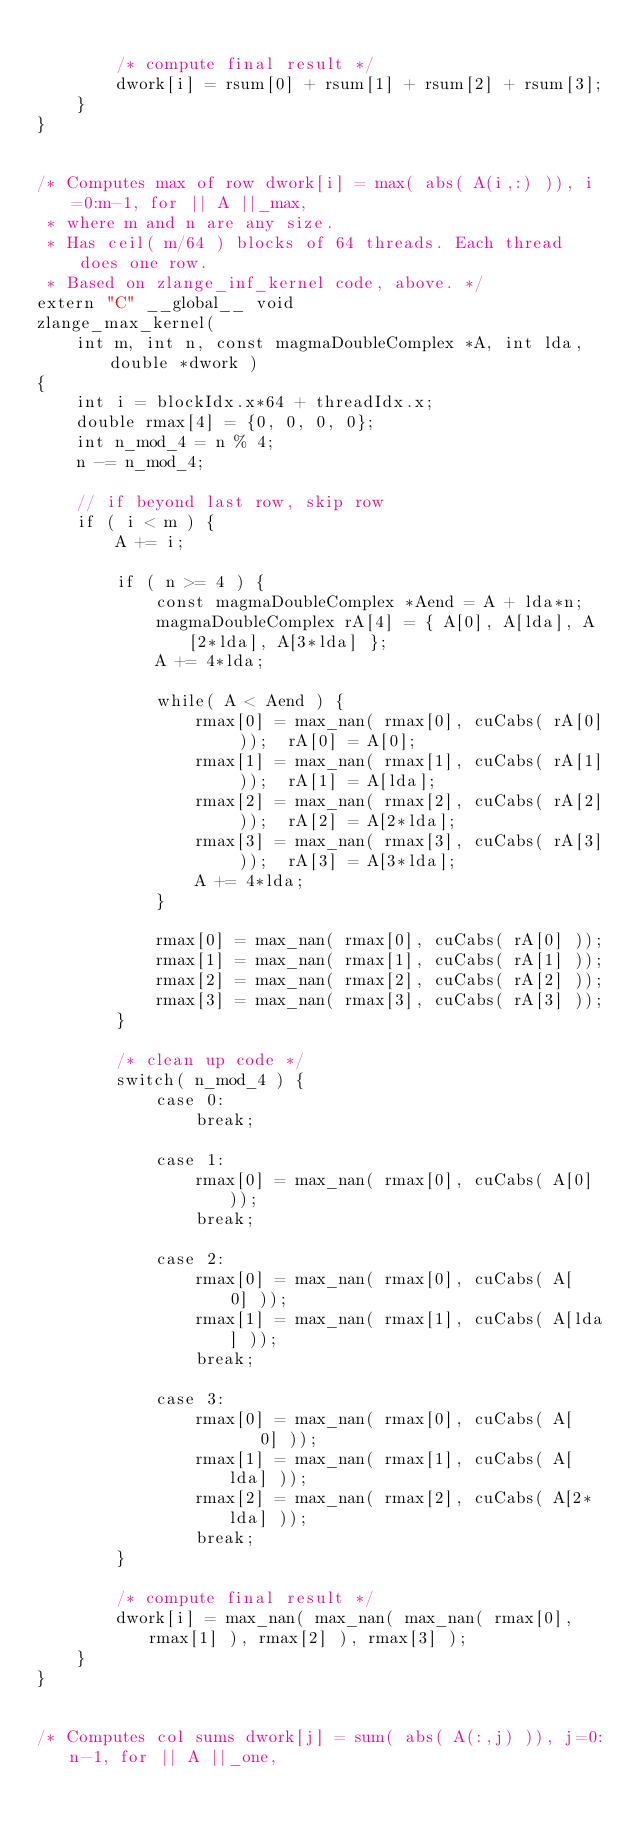Convert code to text. <code><loc_0><loc_0><loc_500><loc_500><_Cuda_>    
        /* compute final result */
        dwork[i] = rsum[0] + rsum[1] + rsum[2] + rsum[3];
    }
}


/* Computes max of row dwork[i] = max( abs( A(i,:) )), i=0:m-1, for || A ||_max,
 * where m and n are any size.
 * Has ceil( m/64 ) blocks of 64 threads. Each thread does one row.
 * Based on zlange_inf_kernel code, above. */
extern "C" __global__ void
zlange_max_kernel(
    int m, int n, const magmaDoubleComplex *A, int lda, double *dwork )
{
    int i = blockIdx.x*64 + threadIdx.x;
    double rmax[4] = {0, 0, 0, 0};
    int n_mod_4 = n % 4;
    n -= n_mod_4;
    
    // if beyond last row, skip row
    if ( i < m ) {
        A += i;
        
        if ( n >= 4 ) {
            const magmaDoubleComplex *Aend = A + lda*n;
            magmaDoubleComplex rA[4] = { A[0], A[lda], A[2*lda], A[3*lda] };
            A += 4*lda;
            
            while( A < Aend ) {
                rmax[0] = max_nan( rmax[0], cuCabs( rA[0] ));  rA[0] = A[0];
                rmax[1] = max_nan( rmax[1], cuCabs( rA[1] ));  rA[1] = A[lda];
                rmax[2] = max_nan( rmax[2], cuCabs( rA[2] ));  rA[2] = A[2*lda];
                rmax[3] = max_nan( rmax[3], cuCabs( rA[3] ));  rA[3] = A[3*lda];
                A += 4*lda;
            }
            
            rmax[0] = max_nan( rmax[0], cuCabs( rA[0] ));
            rmax[1] = max_nan( rmax[1], cuCabs( rA[1] ));
            rmax[2] = max_nan( rmax[2], cuCabs( rA[2] ));
            rmax[3] = max_nan( rmax[3], cuCabs( rA[3] ));
        }
    
        /* clean up code */
        switch( n_mod_4 ) {
            case 0:
                break;
    
            case 1:
                rmax[0] = max_nan( rmax[0], cuCabs( A[0] ));
                break;                          
                                                
            case 2:                             
                rmax[0] = max_nan( rmax[0], cuCabs( A[  0] ));
                rmax[1] = max_nan( rmax[1], cuCabs( A[lda] ));
                break;                          
                                                
            case 3:                             
                rmax[0] = max_nan( rmax[0], cuCabs( A[    0] ));
                rmax[1] = max_nan( rmax[1], cuCabs( A[  lda] ));
                rmax[2] = max_nan( rmax[2], cuCabs( A[2*lda] ));
                break;
        }
    
        /* compute final result */
        dwork[i] = max_nan( max_nan( max_nan( rmax[0], rmax[1] ), rmax[2] ), rmax[3] );
    }
}


/* Computes col sums dwork[j] = sum( abs( A(:,j) )), j=0:n-1, for || A ||_one,</code> 